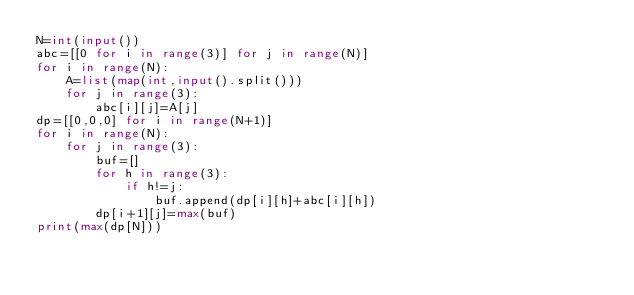<code> <loc_0><loc_0><loc_500><loc_500><_Python_>N=int(input())
abc=[[0 for i in range(3)] for j in range(N)]
for i in range(N):
    A=list(map(int,input().split()))
    for j in range(3):
        abc[i][j]=A[j]
dp=[[0,0,0] for i in range(N+1)]
for i in range(N):
    for j in range(3):
        buf=[]
        for h in range(3):
            if h!=j:
                buf.append(dp[i][h]+abc[i][h])
        dp[i+1][j]=max(buf)
print(max(dp[N]))
</code> 